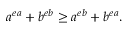Convert formula to latex. <formula><loc_0><loc_0><loc_500><loc_500>a ^ { e a } + b ^ { e b } \geq a ^ { e b } + b ^ { e a } .</formula> 